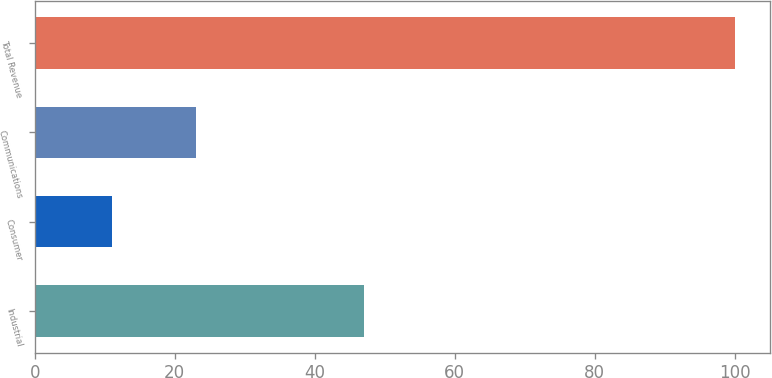Convert chart to OTSL. <chart><loc_0><loc_0><loc_500><loc_500><bar_chart><fcel>Industrial<fcel>Consumer<fcel>Communications<fcel>Total Revenue<nl><fcel>47<fcel>11<fcel>23<fcel>100<nl></chart> 